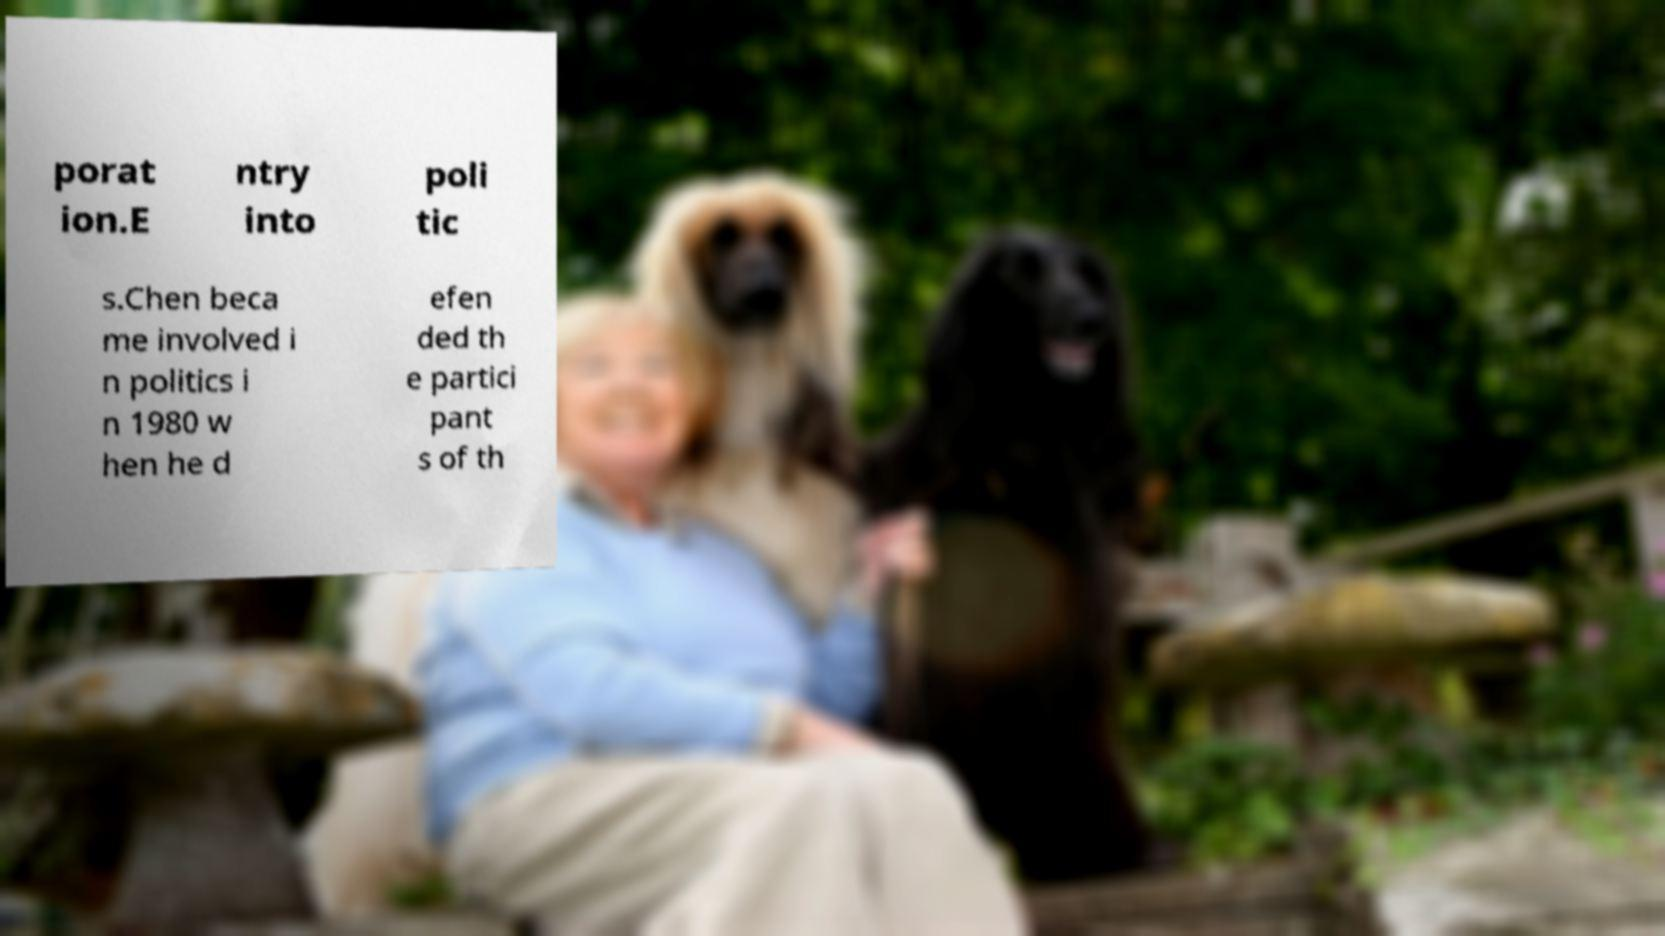Can you accurately transcribe the text from the provided image for me? porat ion.E ntry into poli tic s.Chen beca me involved i n politics i n 1980 w hen he d efen ded th e partici pant s of th 